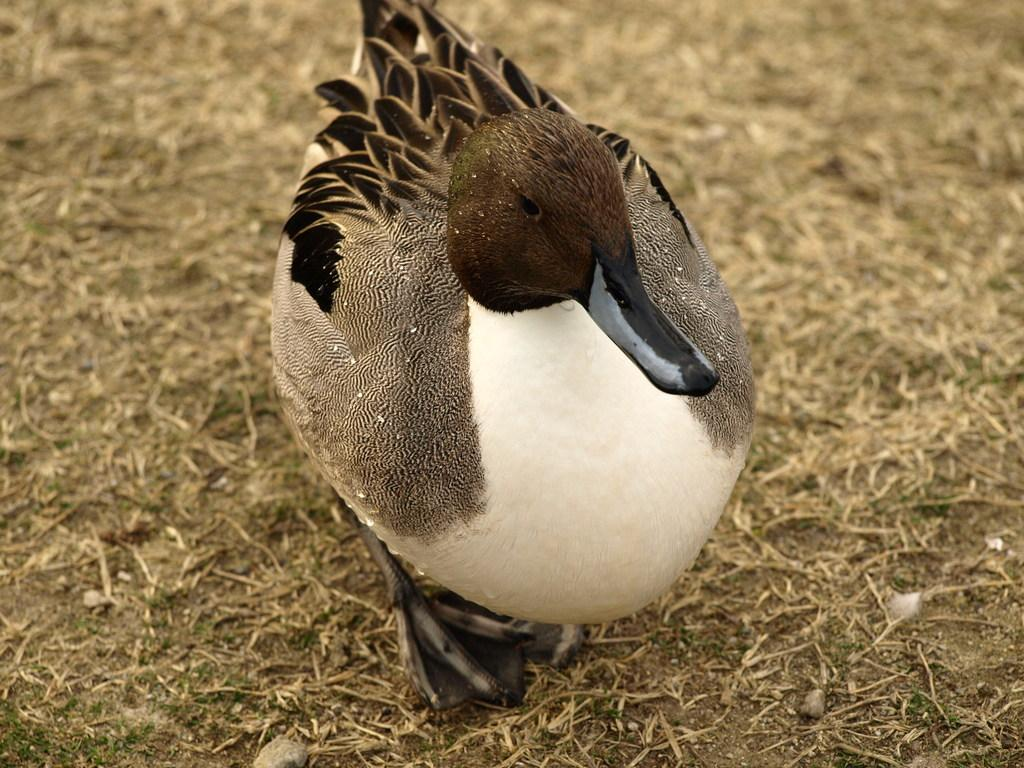What animal is present in the image? There is a duck in the image. Where is the duck located? The duck is on the grass. How many pizzas can be seen in the image? There are no pizzas present in the image. What type of vein is visible on the duck in the image? There is no visible vein on the duck in the image, as it is not a living creature. 